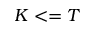Convert formula to latex. <formula><loc_0><loc_0><loc_500><loc_500>K < = T</formula> 